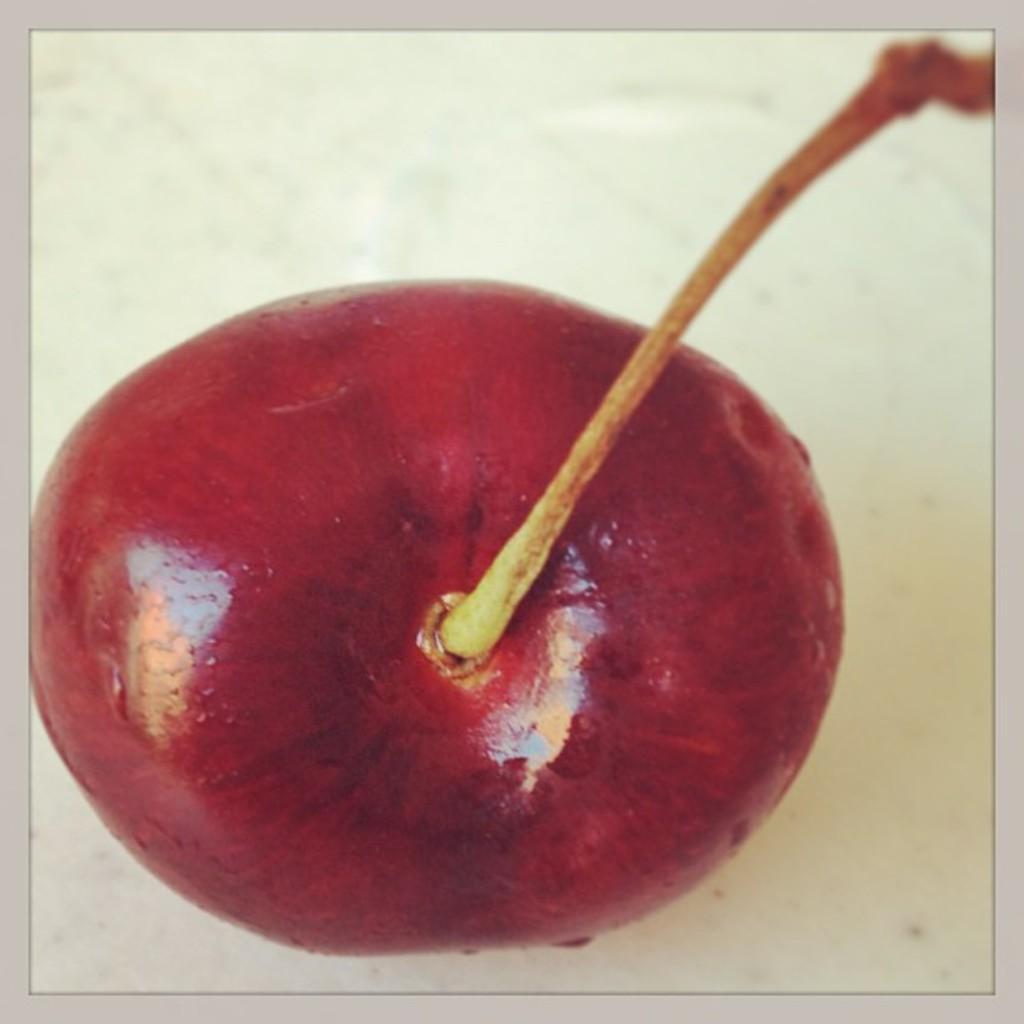Could you give a brief overview of what you see in this image? In this picture we can see the top view of an apple and its twig at the top. 